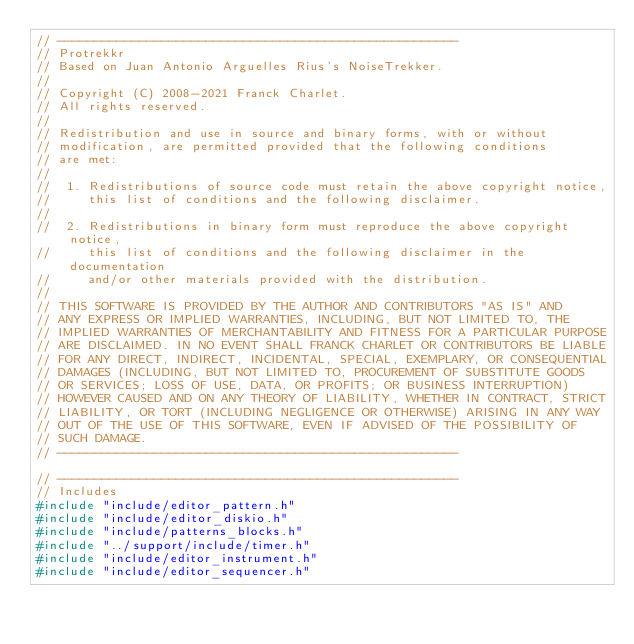Convert code to text. <code><loc_0><loc_0><loc_500><loc_500><_C++_>// ------------------------------------------------------
// Protrekkr
// Based on Juan Antonio Arguelles Rius's NoiseTrekker.
//
// Copyright (C) 2008-2021 Franck Charlet.
// All rights reserved.
//
// Redistribution and use in source and binary forms, with or without
// modification, are permitted provided that the following conditions
// are met:
//
//  1. Redistributions of source code must retain the above copyright notice,
//     this list of conditions and the following disclaimer.
//
//  2. Redistributions in binary form must reproduce the above copyright notice,
//     this list of conditions and the following disclaimer in the documentation
//     and/or other materials provided with the distribution.
//
// THIS SOFTWARE IS PROVIDED BY THE AUTHOR AND CONTRIBUTORS "AS IS" AND
// ANY EXPRESS OR IMPLIED WARRANTIES, INCLUDING, BUT NOT LIMITED TO, THE
// IMPLIED WARRANTIES OF MERCHANTABILITY AND FITNESS FOR A PARTICULAR PURPOSE
// ARE DISCLAIMED. IN NO EVENT SHALL FRANCK CHARLET OR CONTRIBUTORS BE LIABLE
// FOR ANY DIRECT, INDIRECT, INCIDENTAL, SPECIAL, EXEMPLARY, OR CONSEQUENTIAL
// DAMAGES (INCLUDING, BUT NOT LIMITED TO, PROCUREMENT OF SUBSTITUTE GOODS
// OR SERVICES; LOSS OF USE, DATA, OR PROFITS; OR BUSINESS INTERRUPTION)
// HOWEVER CAUSED AND ON ANY THEORY OF LIABILITY, WHETHER IN CONTRACT, STRICT
// LIABILITY, OR TORT (INCLUDING NEGLIGENCE OR OTHERWISE) ARISING IN ANY WAY
// OUT OF THE USE OF THIS SOFTWARE, EVEN IF ADVISED OF THE POSSIBILITY OF
// SUCH DAMAGE.
// ------------------------------------------------------

// ------------------------------------------------------
// Includes
#include "include/editor_pattern.h"
#include "include/editor_diskio.h"
#include "include/patterns_blocks.h"
#include "../support/include/timer.h"
#include "include/editor_instrument.h"
#include "include/editor_sequencer.h"
</code> 